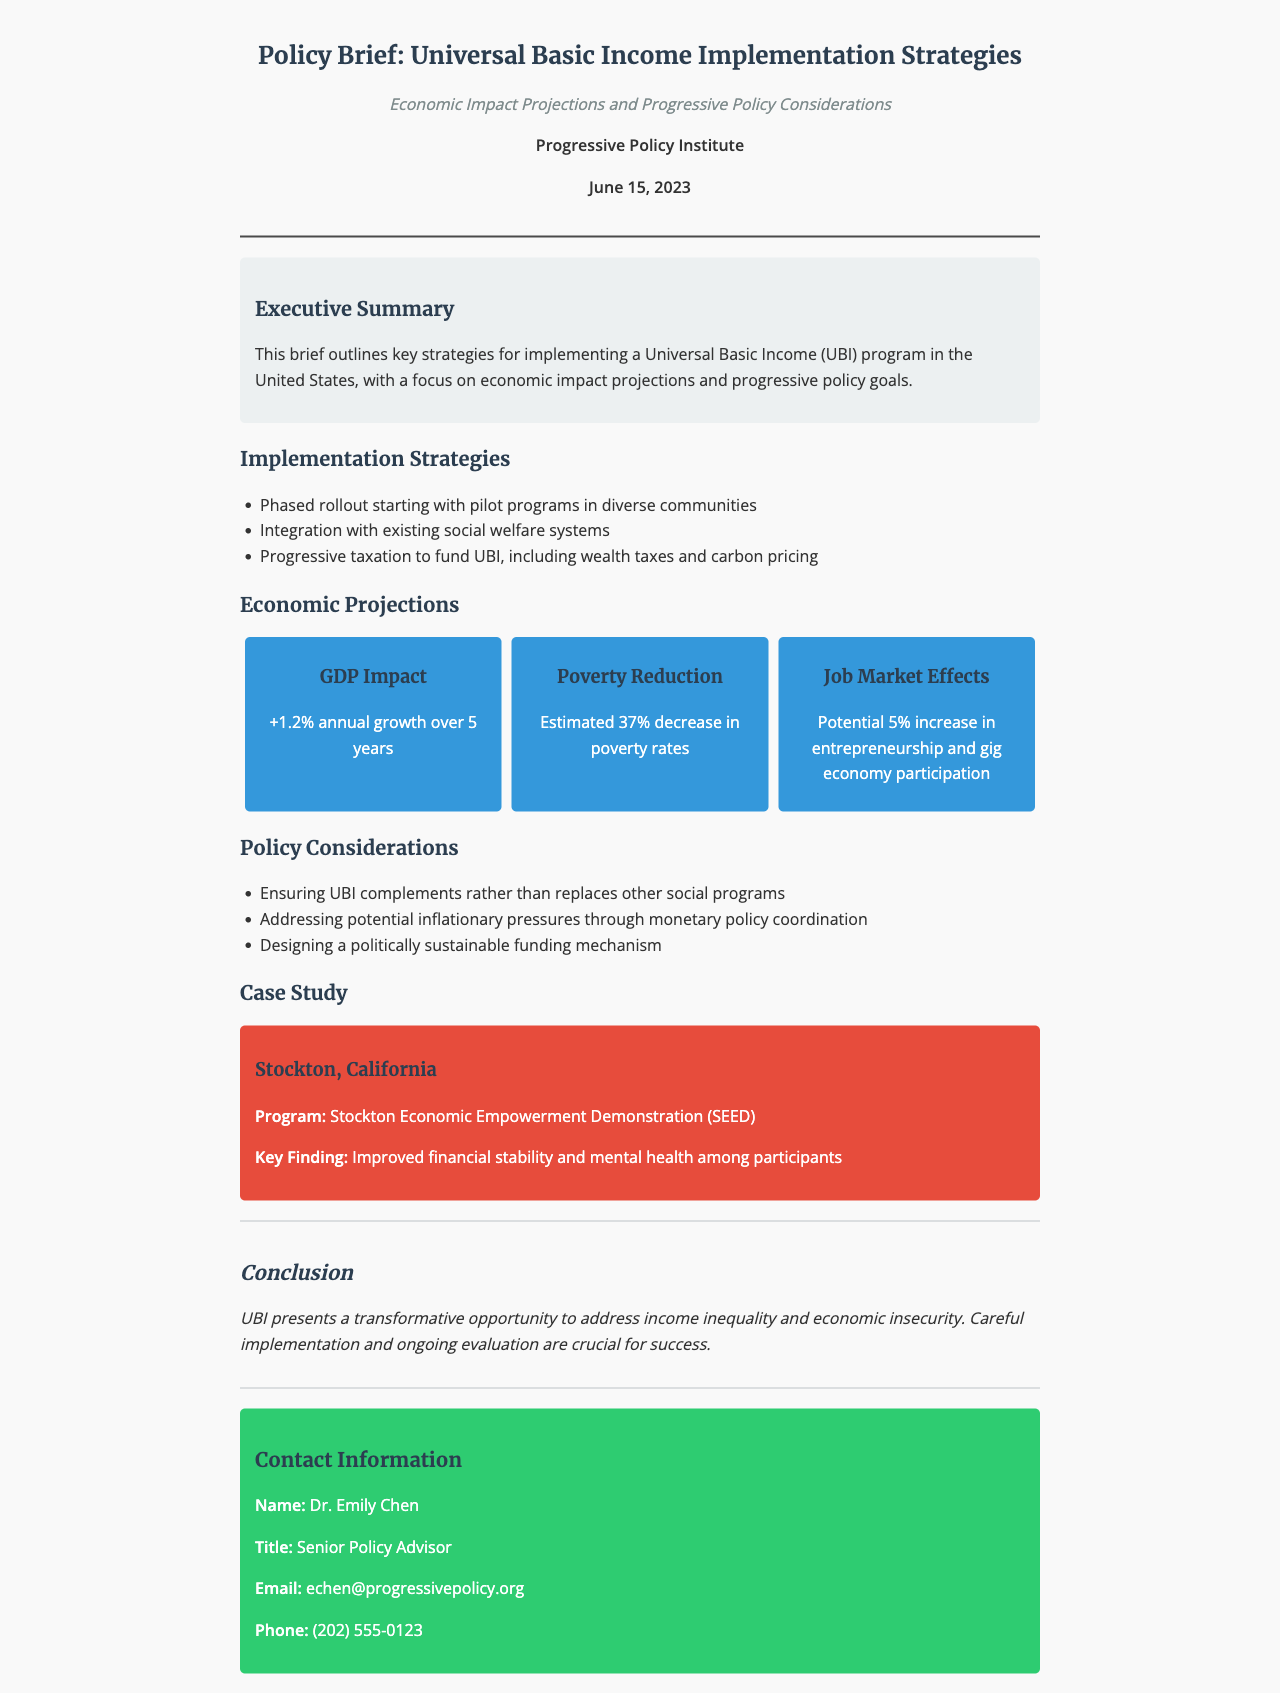What is the title of the policy brief? The title is clearly stated at the top of the document as "Policy Brief: Universal Basic Income Implementation Strategies."
Answer: Universal Basic Income Implementation Strategies Who authored the policy brief? The author is mentioned in the document, indicating the organization responsible for the brief.
Answer: Progressive Policy Institute What is the date of the document? The date of the policy brief is specified in the fax header section.
Answer: June 15, 2023 What is the projected GDP impact of UBI? The document contains a specific projection related to GDP impact.
Answer: +1.2% annual growth over 5 years What is the estimated decrease in poverty rates? The document includes a specific statistic about poverty reduction resulting from UBI.
Answer: 37% decrease in poverty rates Which city was used as a case study? The case study section of the document identifies a specific location relevant to the UBI discussion.
Answer: Stockton, California What is the contact person's title? The contact information section lists the title of the individual for further inquiries.
Answer: Senior Policy Advisor What is one potential funding mechanism for UBI described in the document? The implementation strategies list various funding mechanisms that can support UBI.
Answer: Progressive taxation What key finding came from the Stockton case study? The case study discusses important outcomes related to UBI implementation.
Answer: Improved financial stability and mental health among participants 